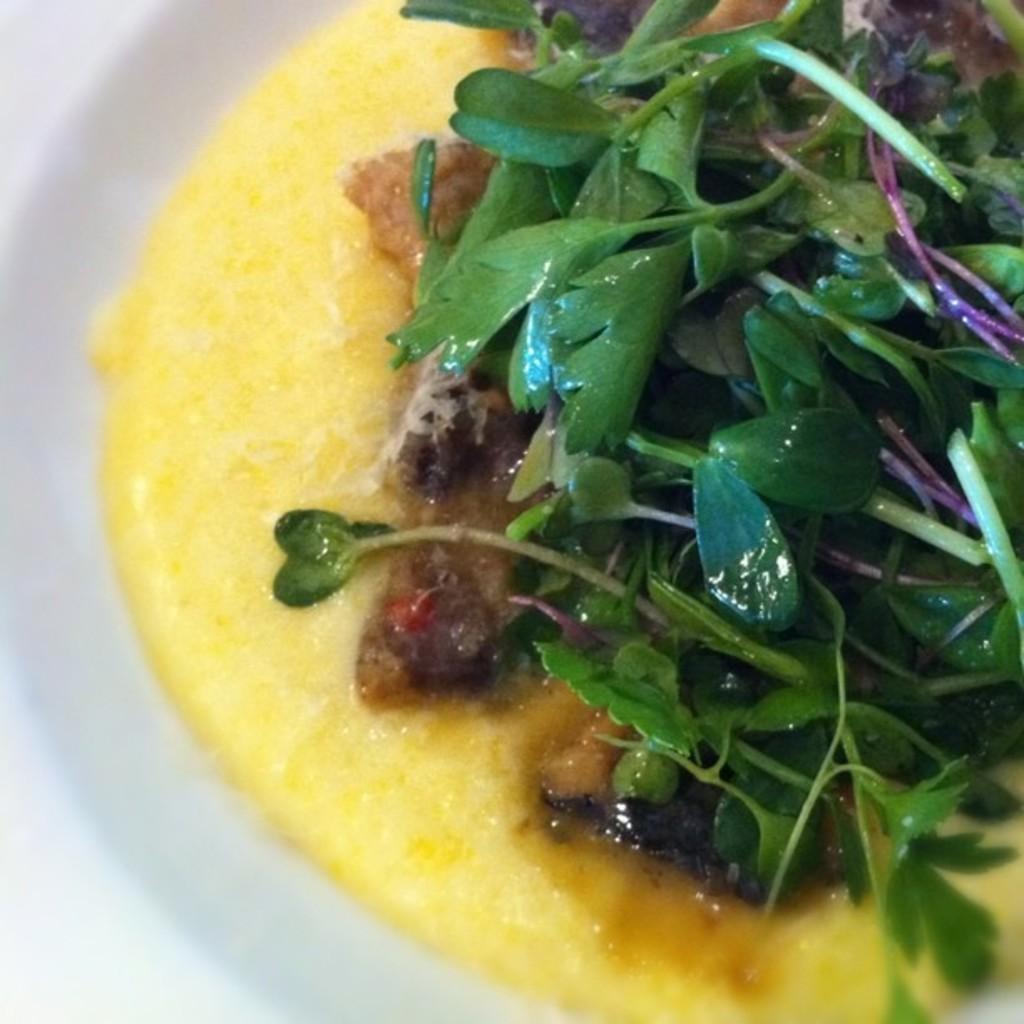In one or two sentences, can you explain what this image depicts? In this image it looks like a plate with some food items. 